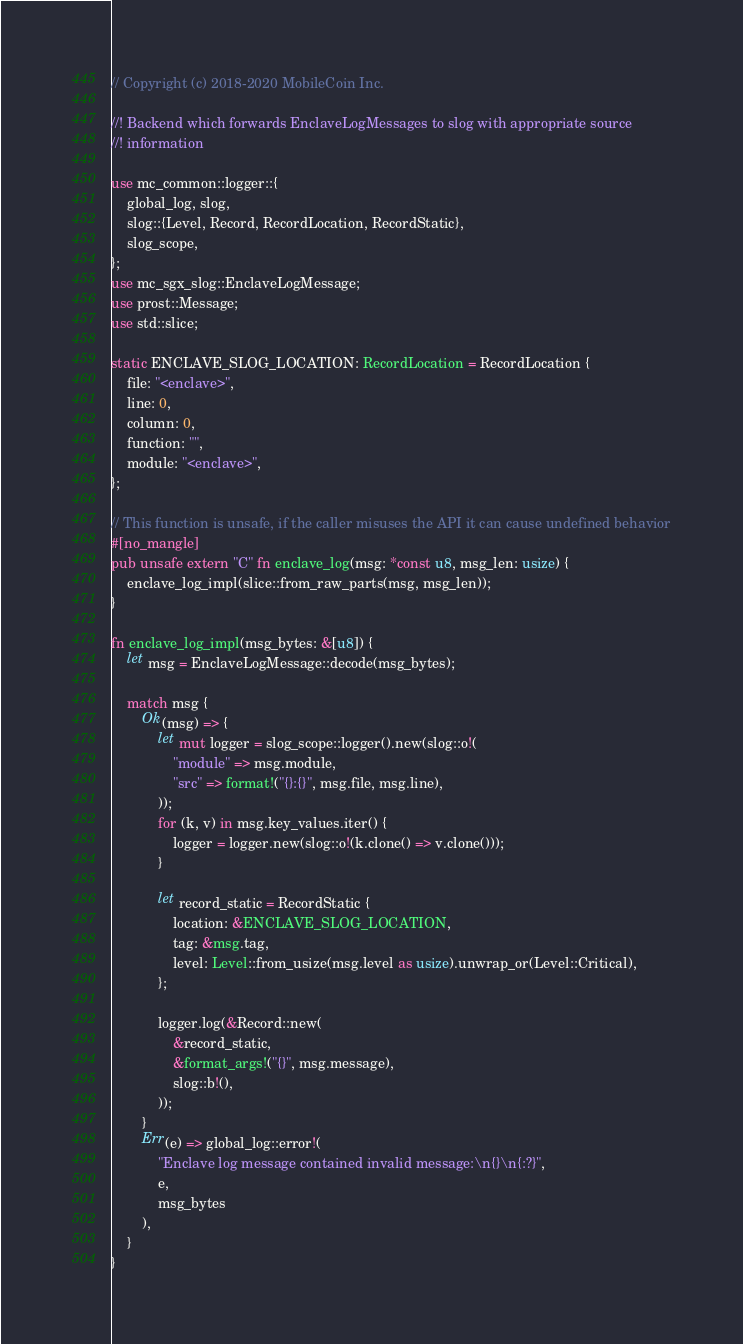<code> <loc_0><loc_0><loc_500><loc_500><_Rust_>// Copyright (c) 2018-2020 MobileCoin Inc.

//! Backend which forwards EnclaveLogMessages to slog with appropriate source
//! information

use mc_common::logger::{
    global_log, slog,
    slog::{Level, Record, RecordLocation, RecordStatic},
    slog_scope,
};
use mc_sgx_slog::EnclaveLogMessage;
use prost::Message;
use std::slice;

static ENCLAVE_SLOG_LOCATION: RecordLocation = RecordLocation {
    file: "<enclave>",
    line: 0,
    column: 0,
    function: "",
    module: "<enclave>",
};

// This function is unsafe, if the caller misuses the API it can cause undefined behavior
#[no_mangle]
pub unsafe extern "C" fn enclave_log(msg: *const u8, msg_len: usize) {
    enclave_log_impl(slice::from_raw_parts(msg, msg_len));
}

fn enclave_log_impl(msg_bytes: &[u8]) {
    let msg = EnclaveLogMessage::decode(msg_bytes);

    match msg {
        Ok(msg) => {
            let mut logger = slog_scope::logger().new(slog::o!(
                "module" => msg.module,
                "src" => format!("{}:{}", msg.file, msg.line),
            ));
            for (k, v) in msg.key_values.iter() {
                logger = logger.new(slog::o!(k.clone() => v.clone()));
            }

            let record_static = RecordStatic {
                location: &ENCLAVE_SLOG_LOCATION,
                tag: &msg.tag,
                level: Level::from_usize(msg.level as usize).unwrap_or(Level::Critical),
            };

            logger.log(&Record::new(
                &record_static,
                &format_args!("{}", msg.message),
                slog::b!(),
            ));
        }
        Err(e) => global_log::error!(
            "Enclave log message contained invalid message:\n{}\n{:?}",
            e,
            msg_bytes
        ),
    }
}
</code> 